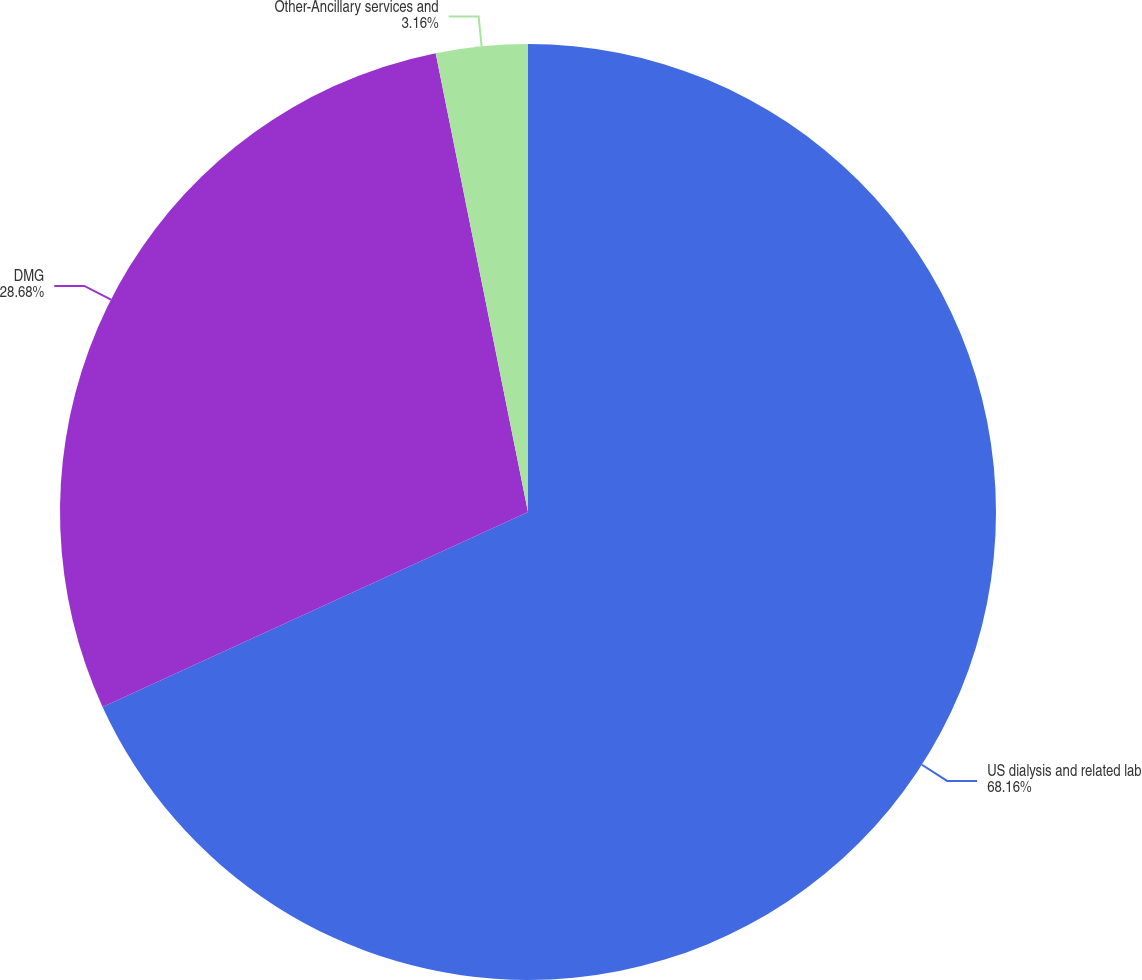<chart> <loc_0><loc_0><loc_500><loc_500><pie_chart><fcel>US dialysis and related lab<fcel>DMG<fcel>Other-Ancillary services and<nl><fcel>68.16%<fcel>28.68%<fcel>3.16%<nl></chart> 